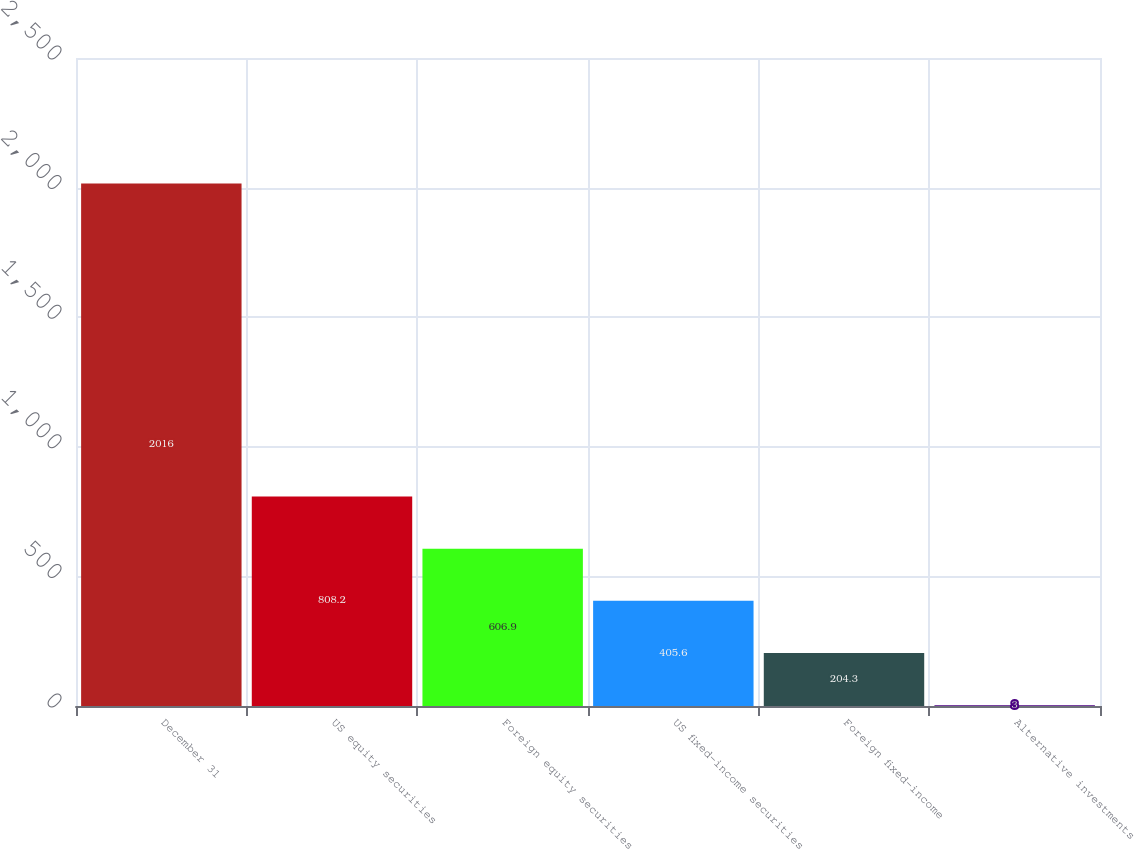Convert chart. <chart><loc_0><loc_0><loc_500><loc_500><bar_chart><fcel>December 31<fcel>US equity securities<fcel>Foreign equity securities<fcel>US fixed-income securities<fcel>Foreign fixed-income<fcel>Alternative investments<nl><fcel>2016<fcel>808.2<fcel>606.9<fcel>405.6<fcel>204.3<fcel>3<nl></chart> 